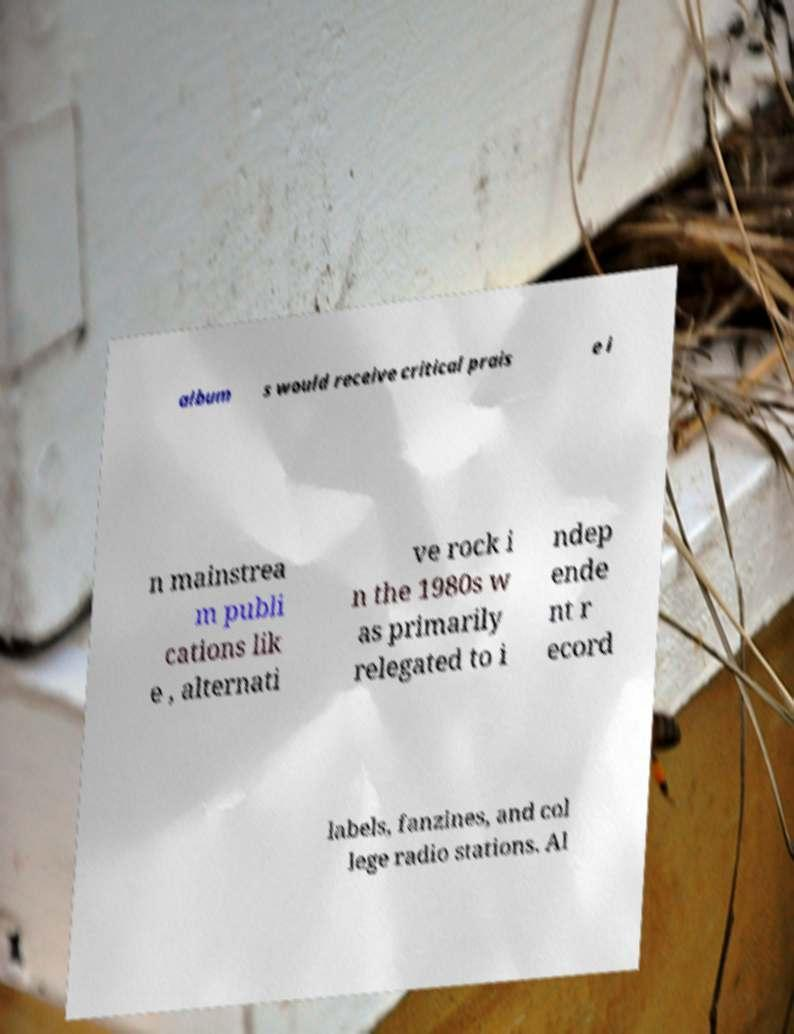Please read and relay the text visible in this image. What does it say? album s would receive critical prais e i n mainstrea m publi cations lik e , alternati ve rock i n the 1980s w as primarily relegated to i ndep ende nt r ecord labels, fanzines, and col lege radio stations. Al 